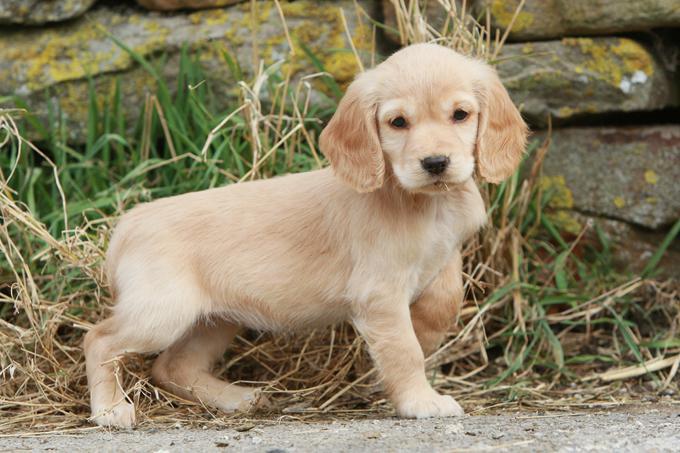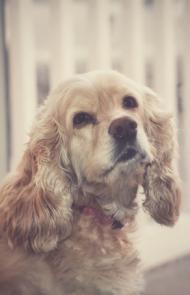The first image is the image on the left, the second image is the image on the right. For the images shown, is this caption "One dog is on the grass, surrounded by grass." true? Answer yes or no. No. 